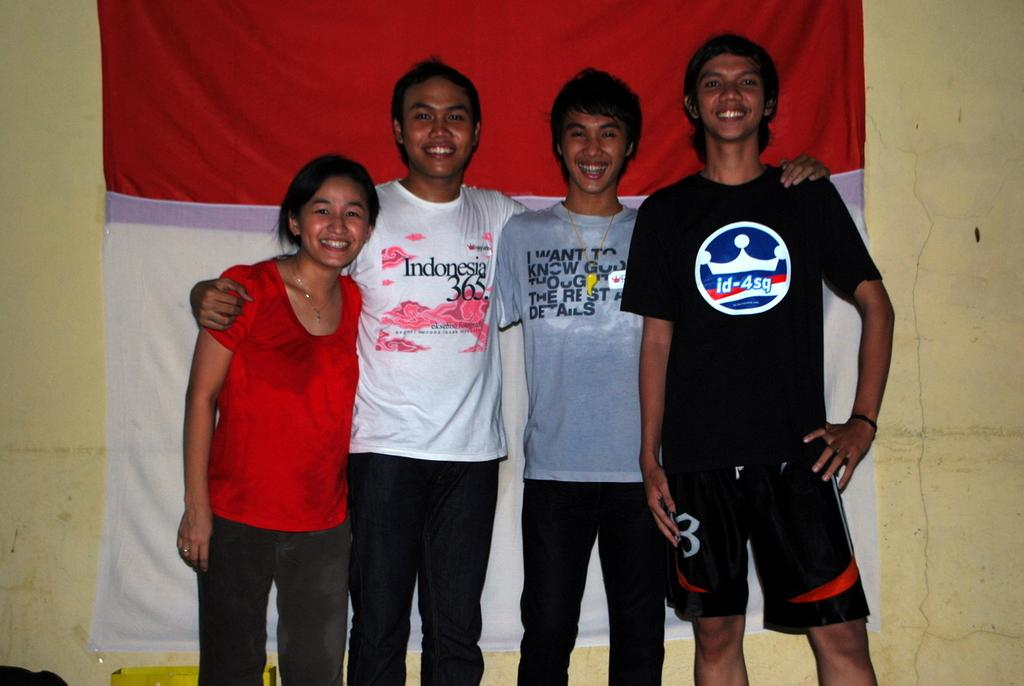<image>
Summarize the visual content of the image. One of the four smiling friends posing in front of a red and white banner wears an Indonesia 365 t-shirt. 